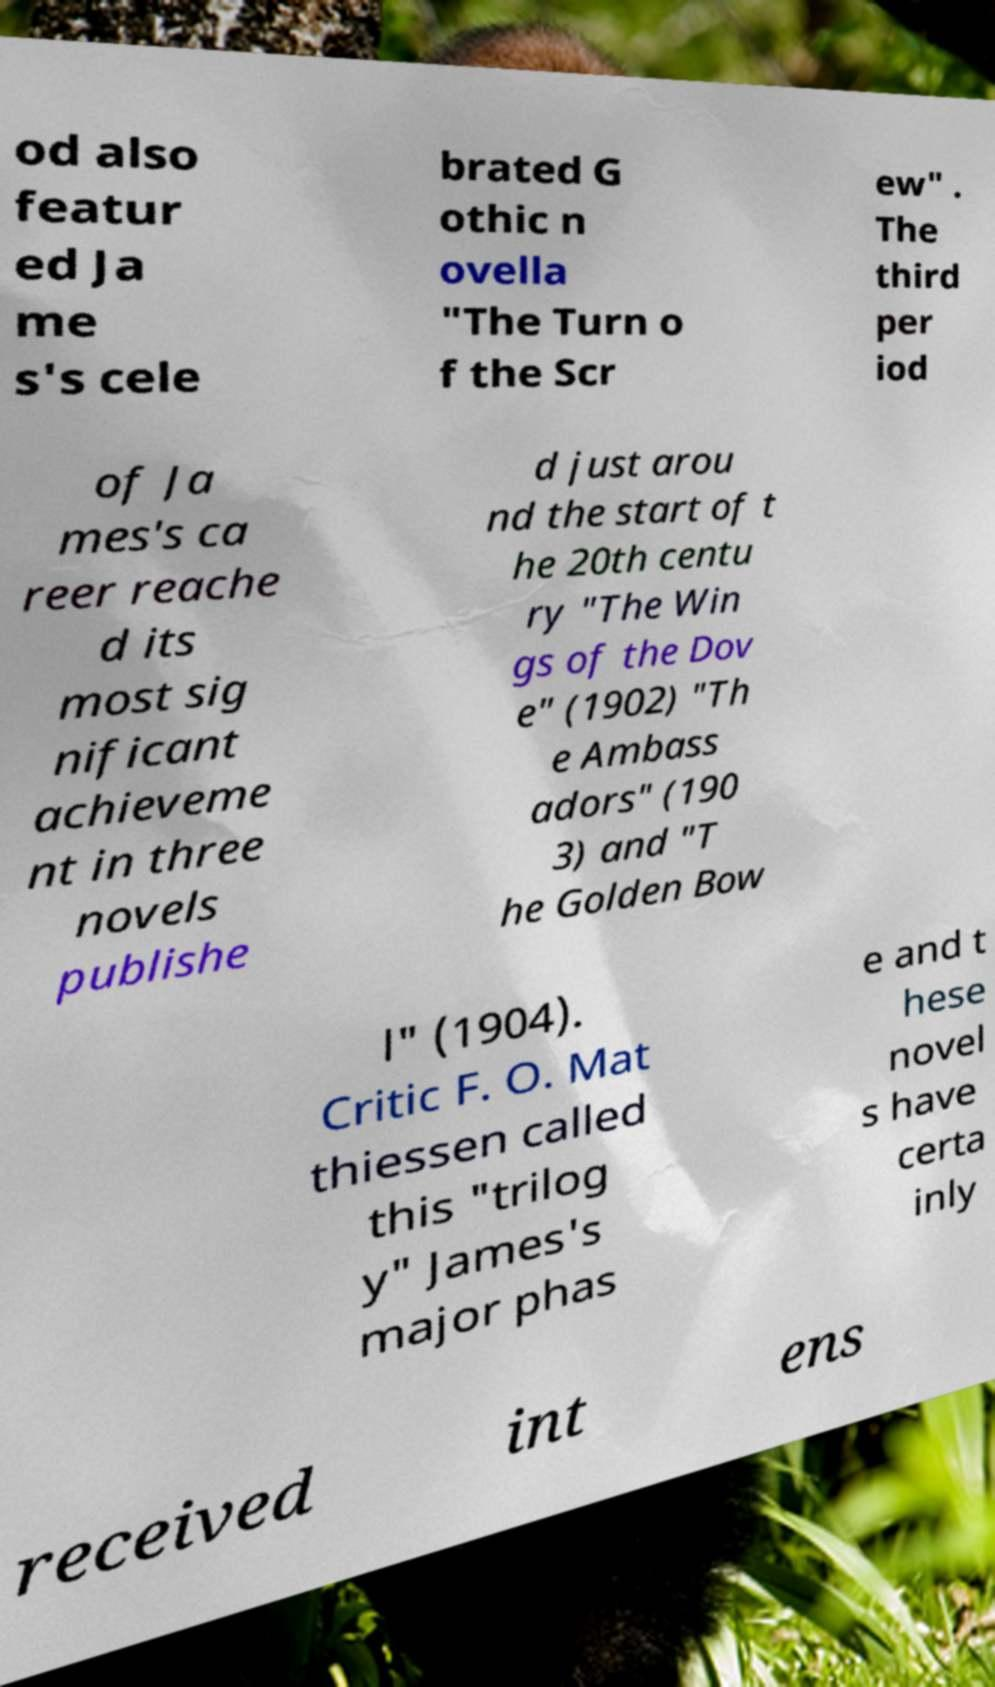There's text embedded in this image that I need extracted. Can you transcribe it verbatim? od also featur ed Ja me s's cele brated G othic n ovella "The Turn o f the Scr ew" . The third per iod of Ja mes's ca reer reache d its most sig nificant achieveme nt in three novels publishe d just arou nd the start of t he 20th centu ry "The Win gs of the Dov e" (1902) "Th e Ambass adors" (190 3) and "T he Golden Bow l" (1904). Critic F. O. Mat thiessen called this "trilog y" James's major phas e and t hese novel s have certa inly received int ens 